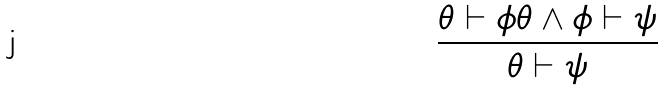Convert formula to latex. <formula><loc_0><loc_0><loc_500><loc_500>\frac { \theta \vdash \phi \theta \wedge \phi \vdash \psi } { \theta \vdash \psi }</formula> 